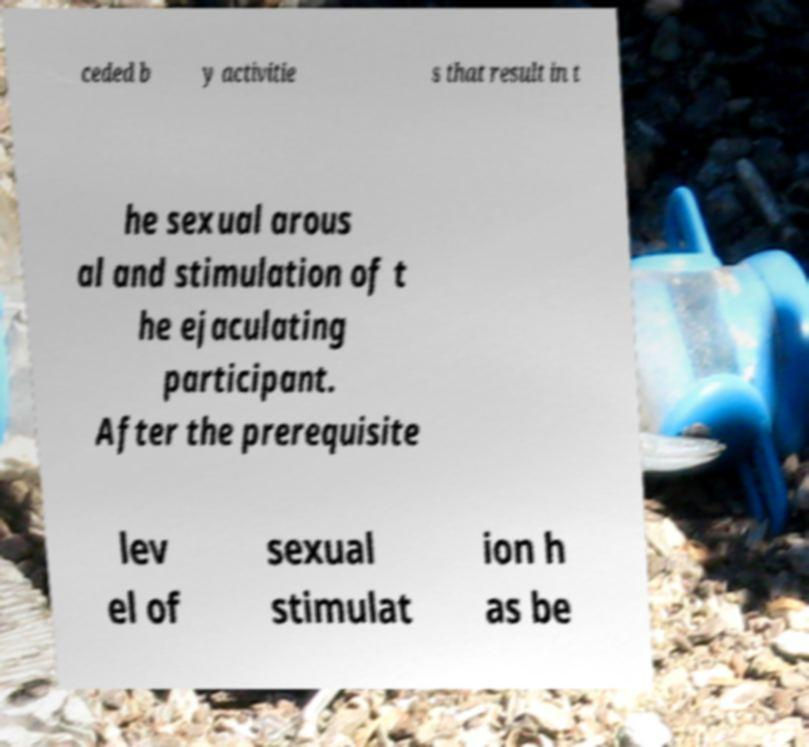For documentation purposes, I need the text within this image transcribed. Could you provide that? ceded b y activitie s that result in t he sexual arous al and stimulation of t he ejaculating participant. After the prerequisite lev el of sexual stimulat ion h as be 